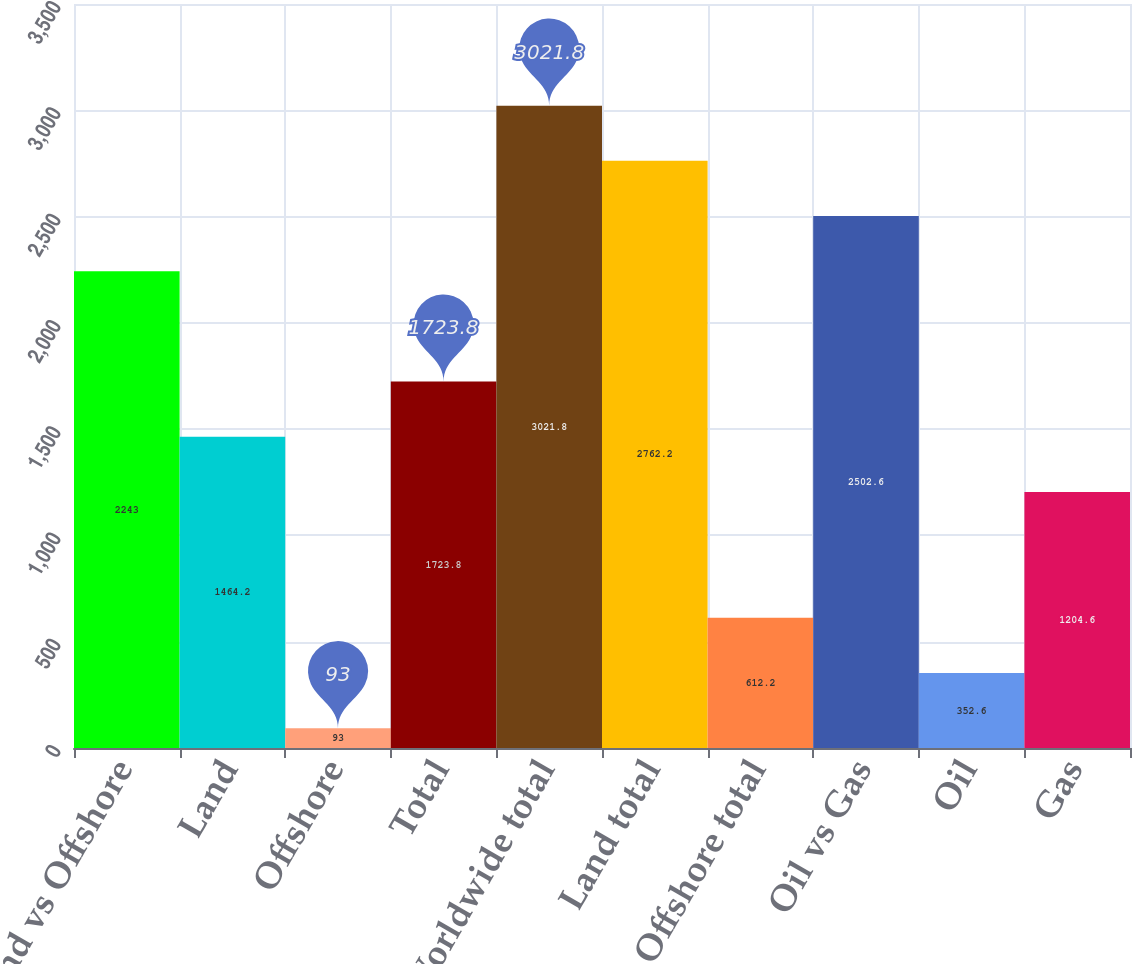<chart> <loc_0><loc_0><loc_500><loc_500><bar_chart><fcel>Land vs Offshore<fcel>Land<fcel>Offshore<fcel>Total<fcel>Worldwide total<fcel>Land total<fcel>Offshore total<fcel>Oil vs Gas<fcel>Oil<fcel>Gas<nl><fcel>2243<fcel>1464.2<fcel>93<fcel>1723.8<fcel>3021.8<fcel>2762.2<fcel>612.2<fcel>2502.6<fcel>352.6<fcel>1204.6<nl></chart> 